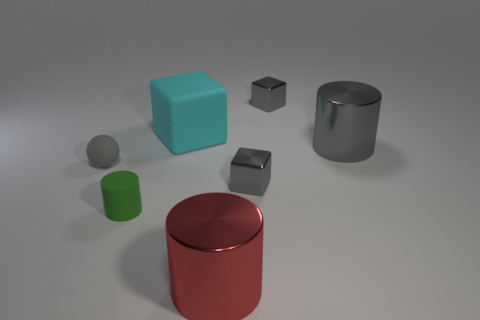Add 1 tiny gray shiny objects. How many objects exist? 8 Subtract all spheres. How many objects are left? 6 Add 6 rubber cubes. How many rubber cubes are left? 7 Add 4 gray cylinders. How many gray cylinders exist? 5 Subtract 0 yellow blocks. How many objects are left? 7 Subtract all matte cylinders. Subtract all large matte things. How many objects are left? 5 